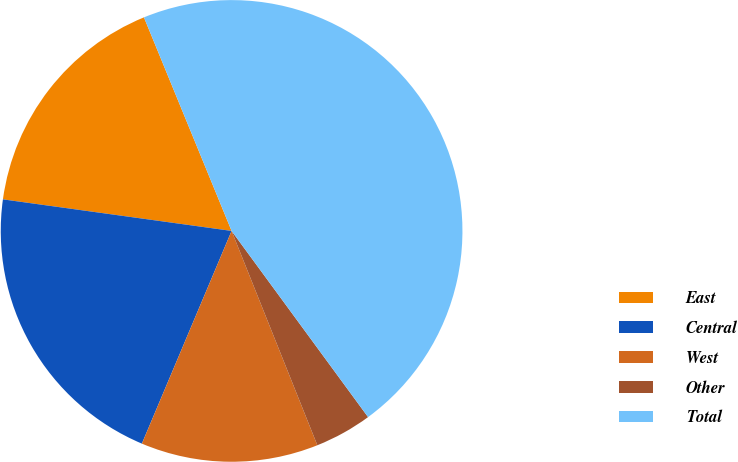Convert chart to OTSL. <chart><loc_0><loc_0><loc_500><loc_500><pie_chart><fcel>East<fcel>Central<fcel>West<fcel>Other<fcel>Total<nl><fcel>16.62%<fcel>20.83%<fcel>12.41%<fcel>4.01%<fcel>46.13%<nl></chart> 